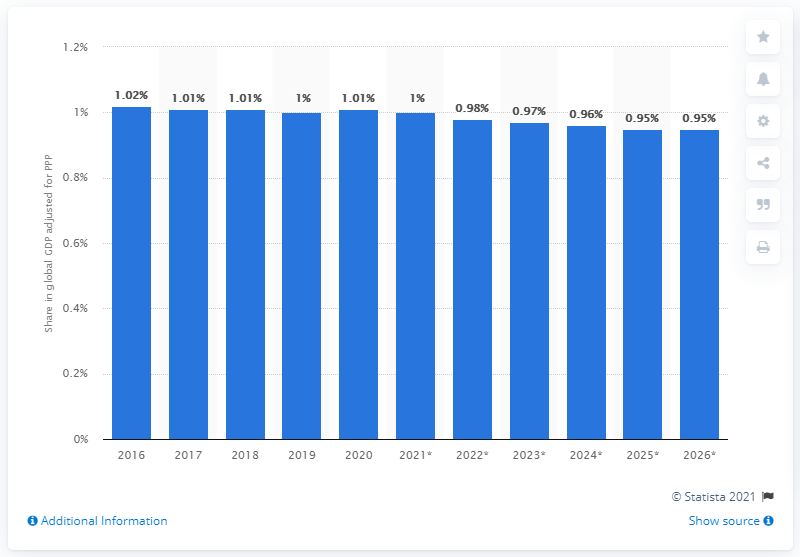Give some essential details in this illustration. In 2020, the Gross Domestic Product (GDP) per capita in Australia was 60,879.57 US dollars. 